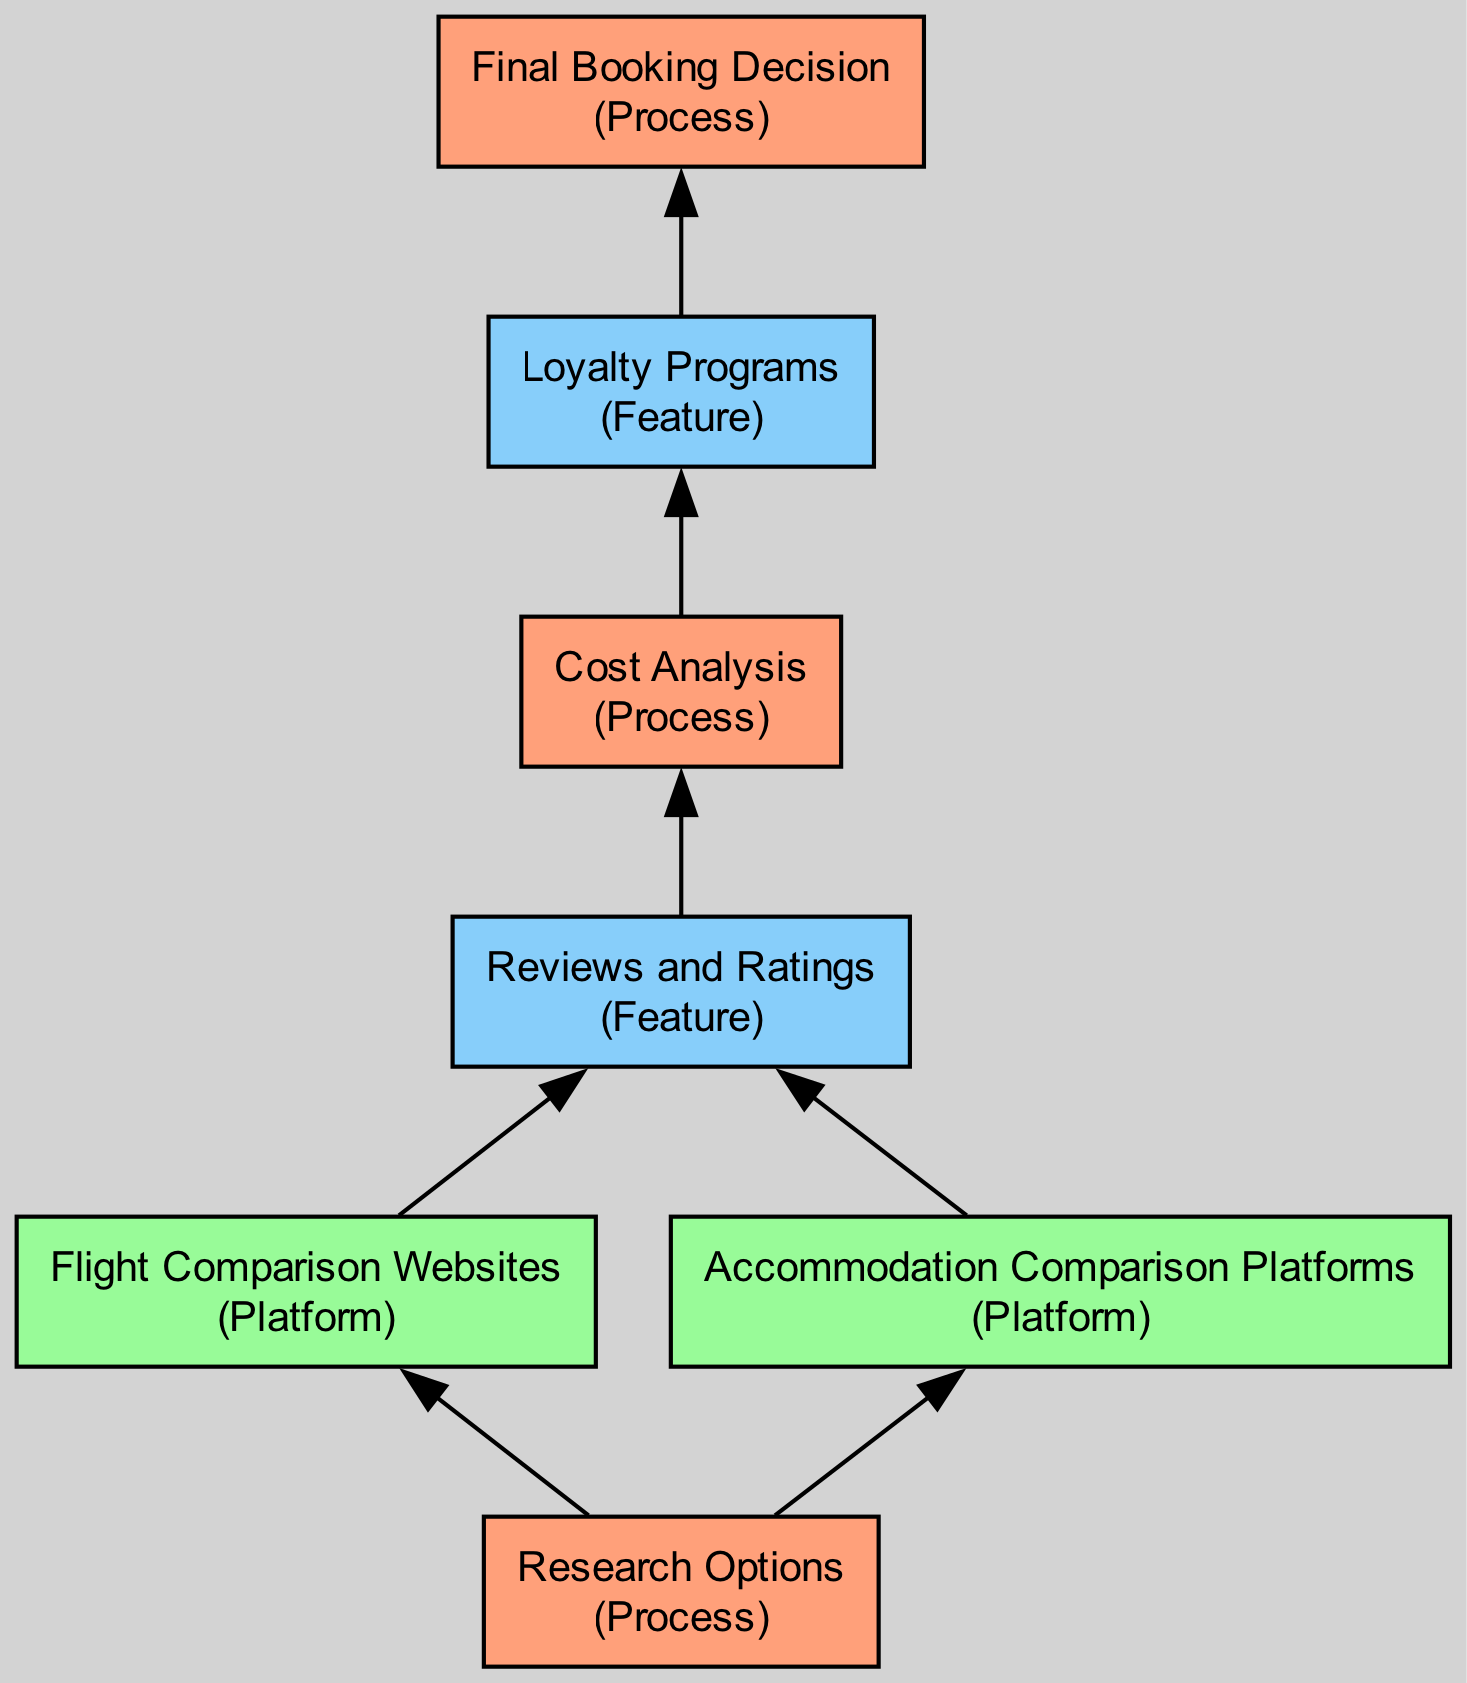What is the starting point of the flow chart? The starting point in the flow chart is 'Research Options', as it is the first node in the bottom-up structure. It initiates the entire booking process by gathering information.
Answer: Research Options How many process nodes are present in the diagram? Upon examining the diagram, we can count the nodes categorized as 'Process'. There are four process nodes: 'Research Options', 'Cost Analysis', 'Final Booking Decision', and 'Loyalty Programs'.
Answer: Four Which platform follows 'Flight Comparison Websites' in the flow chart? Analyzing the flow, the node directly connected to 'Flight Comparison Websites' is 'Reviews and Ratings', indicating the next step involves checking reviews after comparing flights.
Answer: Reviews and Ratings What features are considered in the booking process? The diagram outlines 'Reviews and Ratings' and 'Loyalty Programs' as the features contributing to the booking decision, providing essential information about options and potential advantages.
Answer: Reviews and Ratings, Loyalty Programs Which node connects 'Cost Analysis' to 'Final Booking Decision'? The connecting node is 'Loyalty Programs', which informs the decision-making phase after evaluating costs, considering any applicable discounts or benefits from loyalty programs.
Answer: Loyalty Programs How many edges are present in the flow chart? By counting the directed connections between nodes in the diagram, we find that there are six edges, reflecting the flow of information through the entire booking process.
Answer: Six Which node is a source of information for both flights and accommodations? The node 'Research Options' serves as the common source of information by providing insights into flights and accommodations, thus contributing to both aspects of the booking process.
Answer: Research Options What comes directly after 'Reviews and Ratings' in the flow chart? The node that follows 'Reviews and Ratings' is 'Cost Analysis', which indicates that after reviewing options, the next step is to evaluate total costs including hidden fees and taxes.
Answer: Cost Analysis Which platforms are used for accommodation comparison? The diagram specifies that 'Booking.com', 'Airbnb', and 'Expedia' are platforms designated for comparing accommodations, indicating diverse choices available to travelers.
Answer: Booking.com, Airbnb, Expedia 